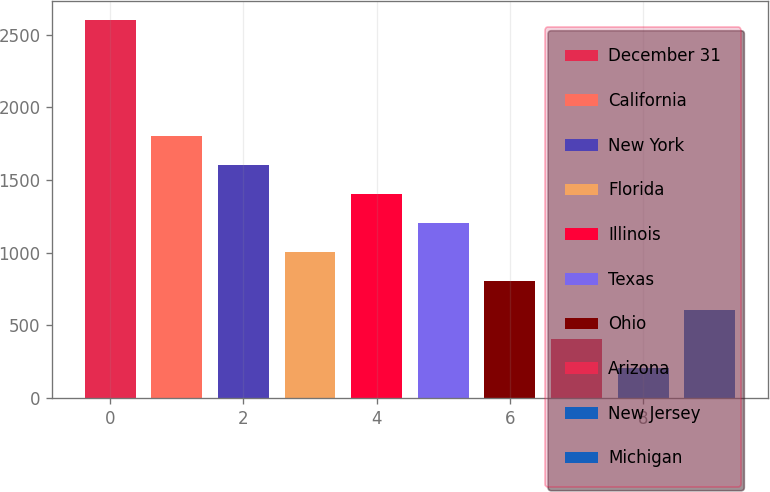<chart> <loc_0><loc_0><loc_500><loc_500><bar_chart><fcel>December 31<fcel>California<fcel>New York<fcel>Florida<fcel>Illinois<fcel>Texas<fcel>Ohio<fcel>Arizona<fcel>New Jersey<fcel>Michigan<nl><fcel>2604.24<fcel>1803.92<fcel>1603.84<fcel>1003.6<fcel>1403.76<fcel>1203.68<fcel>803.52<fcel>403.36<fcel>203.28<fcel>603.44<nl></chart> 